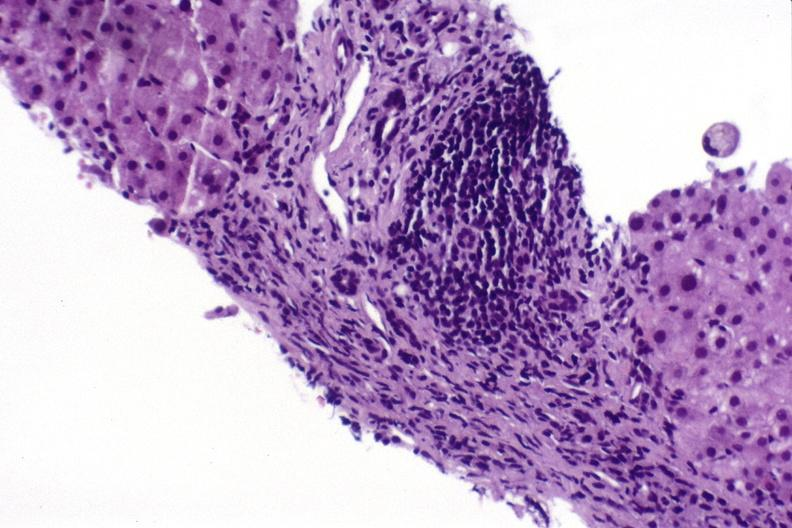what is present?
Answer the question using a single word or phrase. Liver 